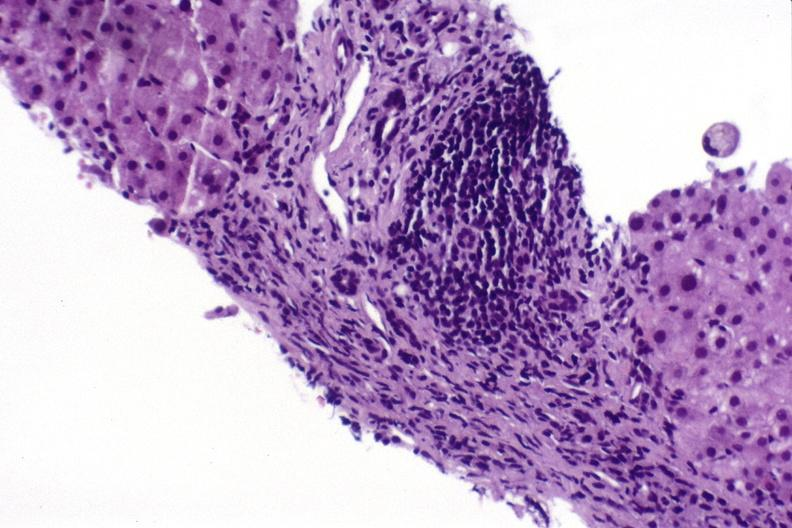what is present?
Answer the question using a single word or phrase. Liver 